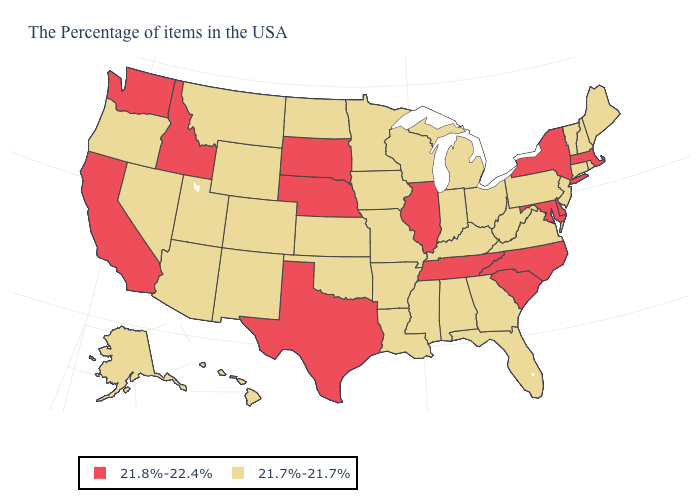Among the states that border Wisconsin , does Minnesota have the highest value?
Concise answer only. No. What is the value of New York?
Keep it brief. 21.8%-22.4%. What is the lowest value in the USA?
Answer briefly. 21.7%-21.7%. What is the lowest value in the South?
Write a very short answer. 21.7%-21.7%. Does Montana have the same value as Minnesota?
Keep it brief. Yes. What is the value of West Virginia?
Keep it brief. 21.7%-21.7%. Does Alaska have the highest value in the USA?
Answer briefly. No. Does Nevada have the highest value in the USA?
Quick response, please. No. Which states have the highest value in the USA?
Give a very brief answer. Massachusetts, New York, Delaware, Maryland, North Carolina, South Carolina, Tennessee, Illinois, Nebraska, Texas, South Dakota, Idaho, California, Washington. Among the states that border Illinois , which have the lowest value?
Be succinct. Kentucky, Indiana, Wisconsin, Missouri, Iowa. Does the map have missing data?
Answer briefly. No. What is the highest value in the South ?
Answer briefly. 21.8%-22.4%. What is the value of Ohio?
Write a very short answer. 21.7%-21.7%. Name the states that have a value in the range 21.7%-21.7%?
Quick response, please. Maine, Rhode Island, New Hampshire, Vermont, Connecticut, New Jersey, Pennsylvania, Virginia, West Virginia, Ohio, Florida, Georgia, Michigan, Kentucky, Indiana, Alabama, Wisconsin, Mississippi, Louisiana, Missouri, Arkansas, Minnesota, Iowa, Kansas, Oklahoma, North Dakota, Wyoming, Colorado, New Mexico, Utah, Montana, Arizona, Nevada, Oregon, Alaska, Hawaii. What is the value of Illinois?
Concise answer only. 21.8%-22.4%. 